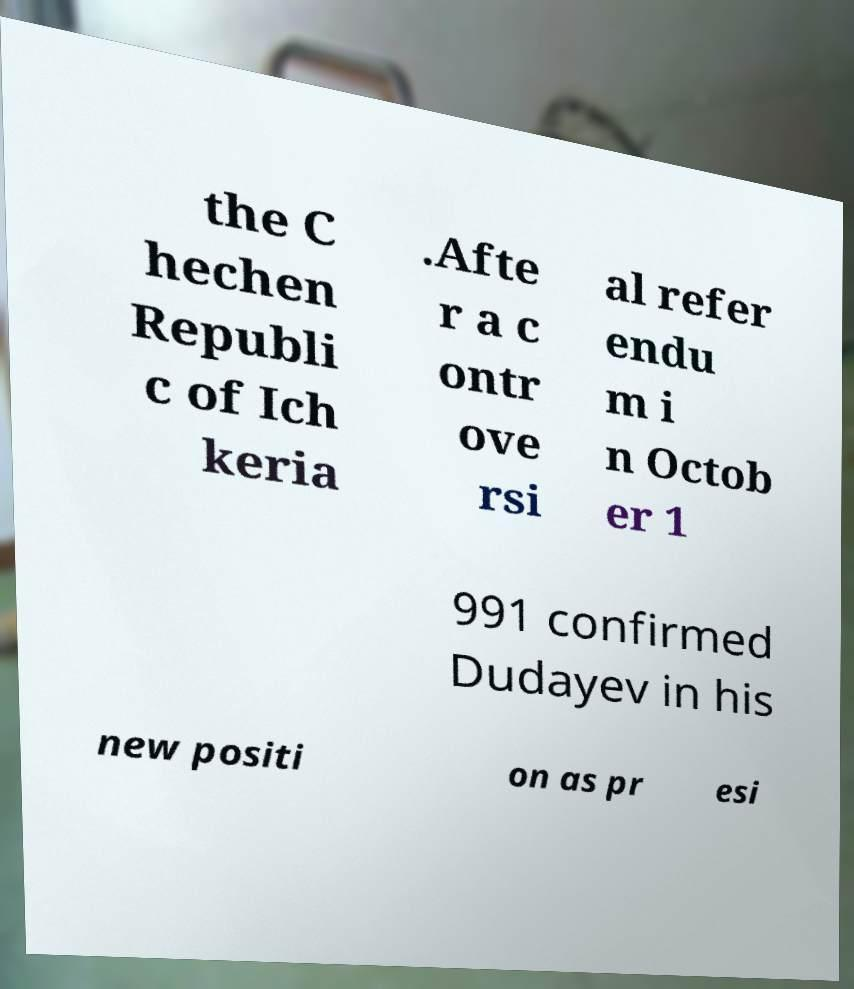There's text embedded in this image that I need extracted. Can you transcribe it verbatim? the C hechen Republi c of Ich keria .Afte r a c ontr ove rsi al refer endu m i n Octob er 1 991 confirmed Dudayev in his new positi on as pr esi 